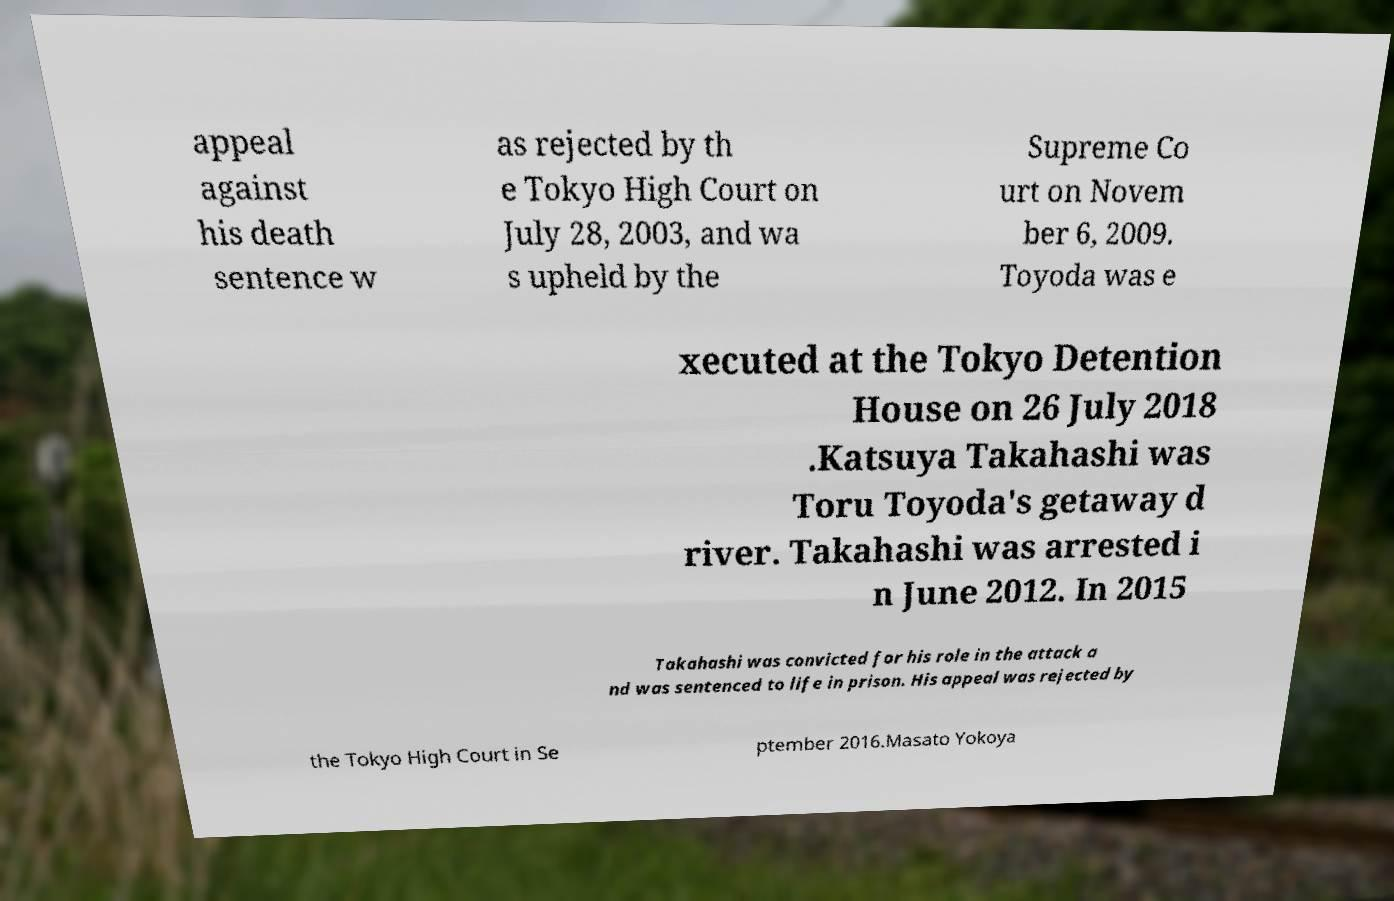Could you extract and type out the text from this image? appeal against his death sentence w as rejected by th e Tokyo High Court on July 28, 2003, and wa s upheld by the Supreme Co urt on Novem ber 6, 2009. Toyoda was e xecuted at the Tokyo Detention House on 26 July 2018 .Katsuya Takahashi was Toru Toyoda's getaway d river. Takahashi was arrested i n June 2012. In 2015 Takahashi was convicted for his role in the attack a nd was sentenced to life in prison. His appeal was rejected by the Tokyo High Court in Se ptember 2016.Masato Yokoya 